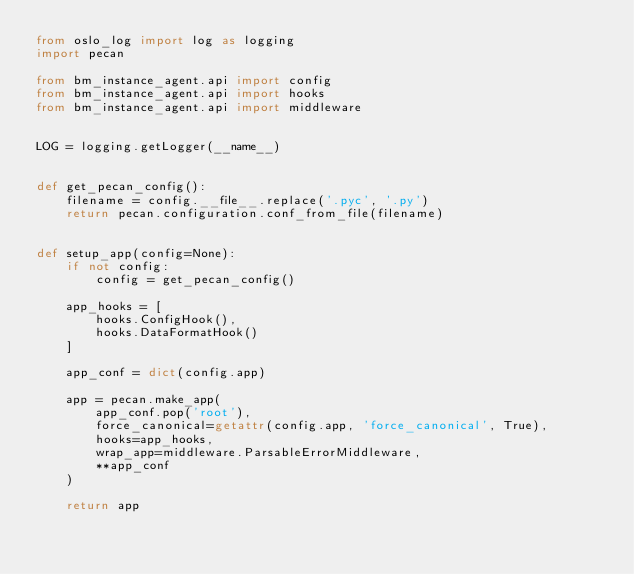Convert code to text. <code><loc_0><loc_0><loc_500><loc_500><_Python_>from oslo_log import log as logging
import pecan

from bm_instance_agent.api import config
from bm_instance_agent.api import hooks
from bm_instance_agent.api import middleware


LOG = logging.getLogger(__name__)


def get_pecan_config():
    filename = config.__file__.replace('.pyc', '.py')
    return pecan.configuration.conf_from_file(filename)


def setup_app(config=None):
    if not config:
        config = get_pecan_config()

    app_hooks = [
        hooks.ConfigHook(),
        hooks.DataFormatHook()
    ]

    app_conf = dict(config.app)

    app = pecan.make_app(
        app_conf.pop('root'),
        force_canonical=getattr(config.app, 'force_canonical', True),
        hooks=app_hooks,
        wrap_app=middleware.ParsableErrorMiddleware,
        **app_conf
    )

    return app
</code> 